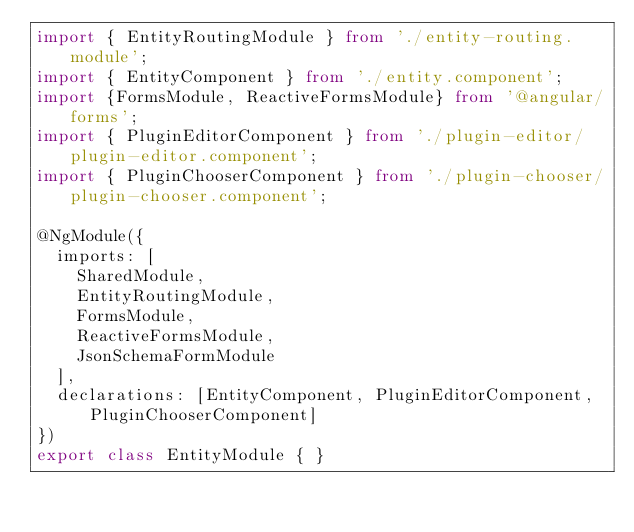Convert code to text. <code><loc_0><loc_0><loc_500><loc_500><_TypeScript_>import { EntityRoutingModule } from './entity-routing.module';
import { EntityComponent } from './entity.component';
import {FormsModule, ReactiveFormsModule} from '@angular/forms';
import { PluginEditorComponent } from './plugin-editor/plugin-editor.component';
import { PluginChooserComponent } from './plugin-chooser/plugin-chooser.component';

@NgModule({
  imports: [
    SharedModule,
    EntityRoutingModule,
    FormsModule,
    ReactiveFormsModule,
    JsonSchemaFormModule
  ],
  declarations: [EntityComponent, PluginEditorComponent, PluginChooserComponent]
})
export class EntityModule { }
</code> 